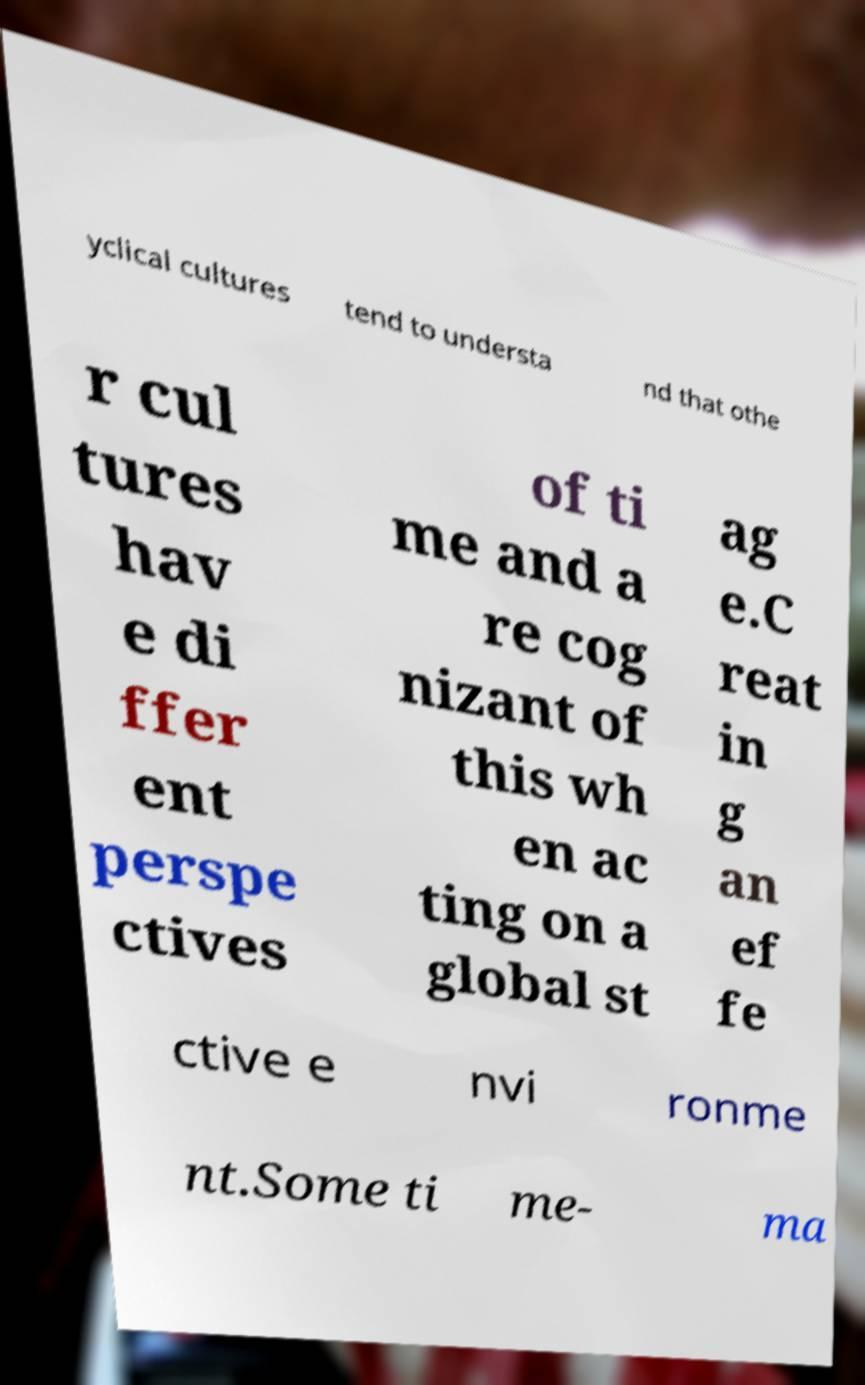Can you accurately transcribe the text from the provided image for me? yclical cultures tend to understa nd that othe r cul tures hav e di ffer ent perspe ctives of ti me and a re cog nizant of this wh en ac ting on a global st ag e.C reat in g an ef fe ctive e nvi ronme nt.Some ti me- ma 